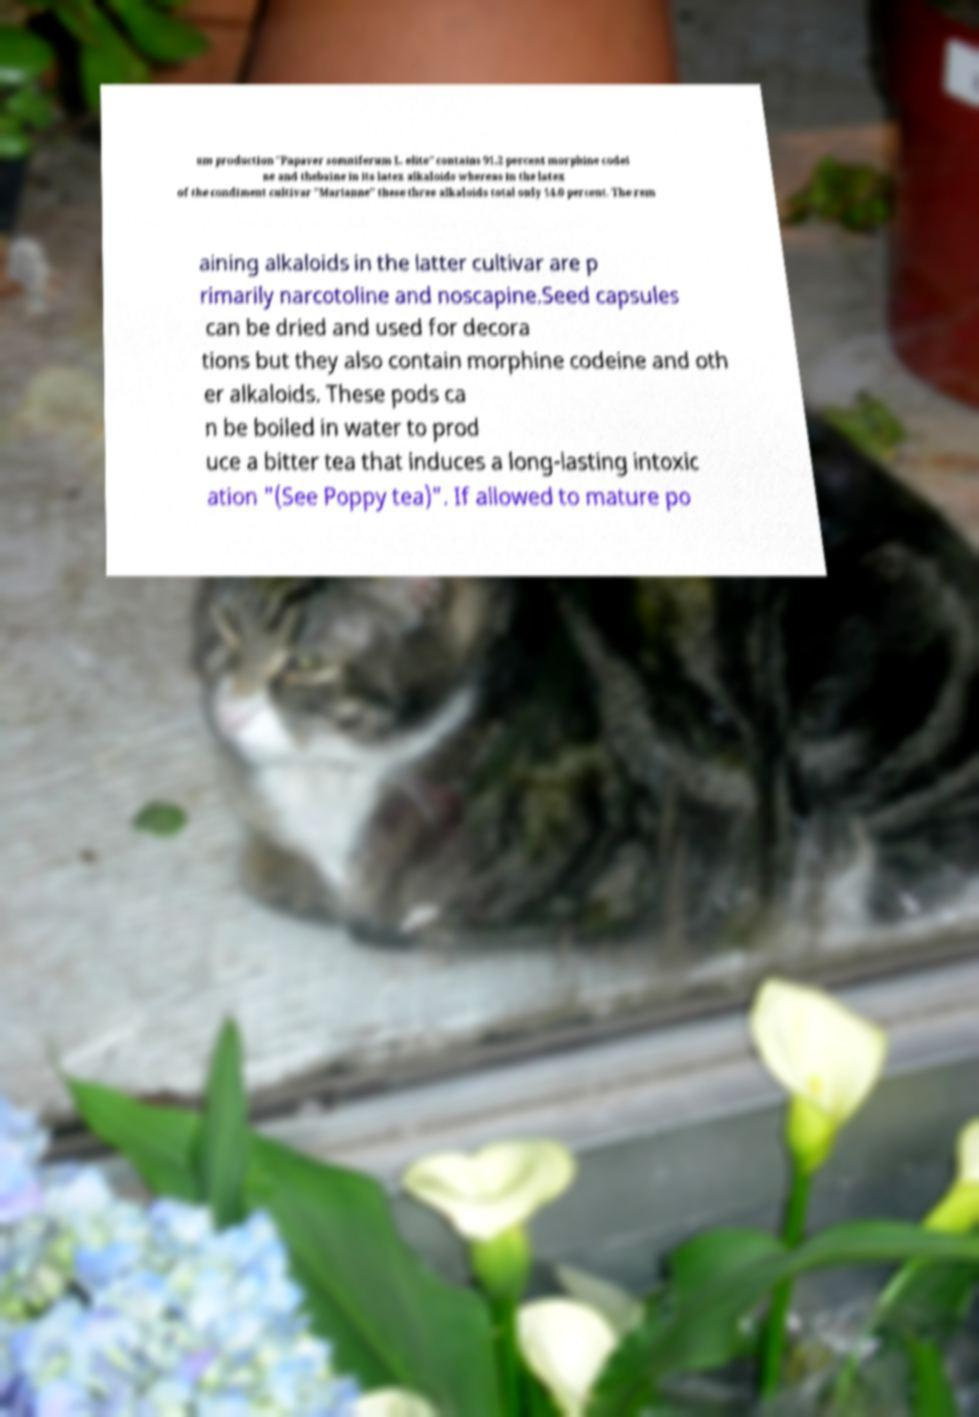Please read and relay the text visible in this image. What does it say? um production "Papaver somniferum L. elite" contains 91.2 percent morphine codei ne and thebaine in its latex alkaloids whereas in the latex of the condiment cultivar "Marianne" these three alkaloids total only 14.0 percent. The rem aining alkaloids in the latter cultivar are p rimarily narcotoline and noscapine.Seed capsules can be dried and used for decora tions but they also contain morphine codeine and oth er alkaloids. These pods ca n be boiled in water to prod uce a bitter tea that induces a long-lasting intoxic ation "(See Poppy tea)". If allowed to mature po 